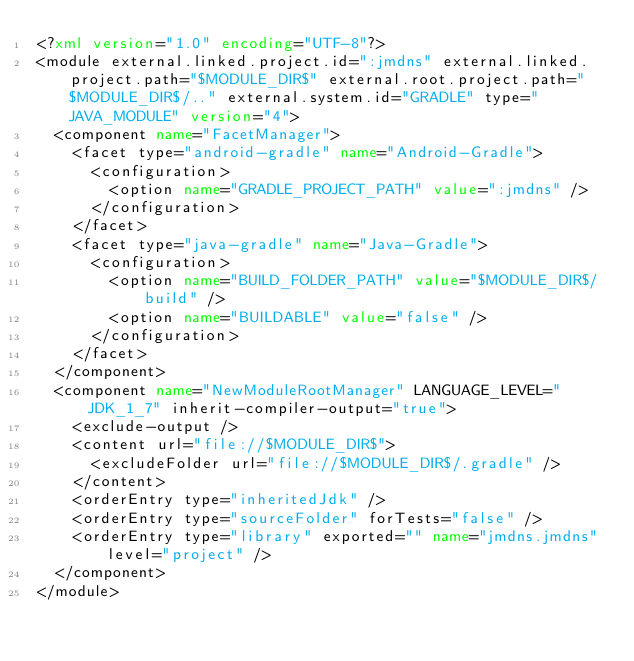<code> <loc_0><loc_0><loc_500><loc_500><_XML_><?xml version="1.0" encoding="UTF-8"?>
<module external.linked.project.id=":jmdns" external.linked.project.path="$MODULE_DIR$" external.root.project.path="$MODULE_DIR$/.." external.system.id="GRADLE" type="JAVA_MODULE" version="4">
  <component name="FacetManager">
    <facet type="android-gradle" name="Android-Gradle">
      <configuration>
        <option name="GRADLE_PROJECT_PATH" value=":jmdns" />
      </configuration>
    </facet>
    <facet type="java-gradle" name="Java-Gradle">
      <configuration>
        <option name="BUILD_FOLDER_PATH" value="$MODULE_DIR$/build" />
        <option name="BUILDABLE" value="false" />
      </configuration>
    </facet>
  </component>
  <component name="NewModuleRootManager" LANGUAGE_LEVEL="JDK_1_7" inherit-compiler-output="true">
    <exclude-output />
    <content url="file://$MODULE_DIR$">
      <excludeFolder url="file://$MODULE_DIR$/.gradle" />
    </content>
    <orderEntry type="inheritedJdk" />
    <orderEntry type="sourceFolder" forTests="false" />
    <orderEntry type="library" exported="" name="jmdns.jmdns" level="project" />
  </component>
</module></code> 